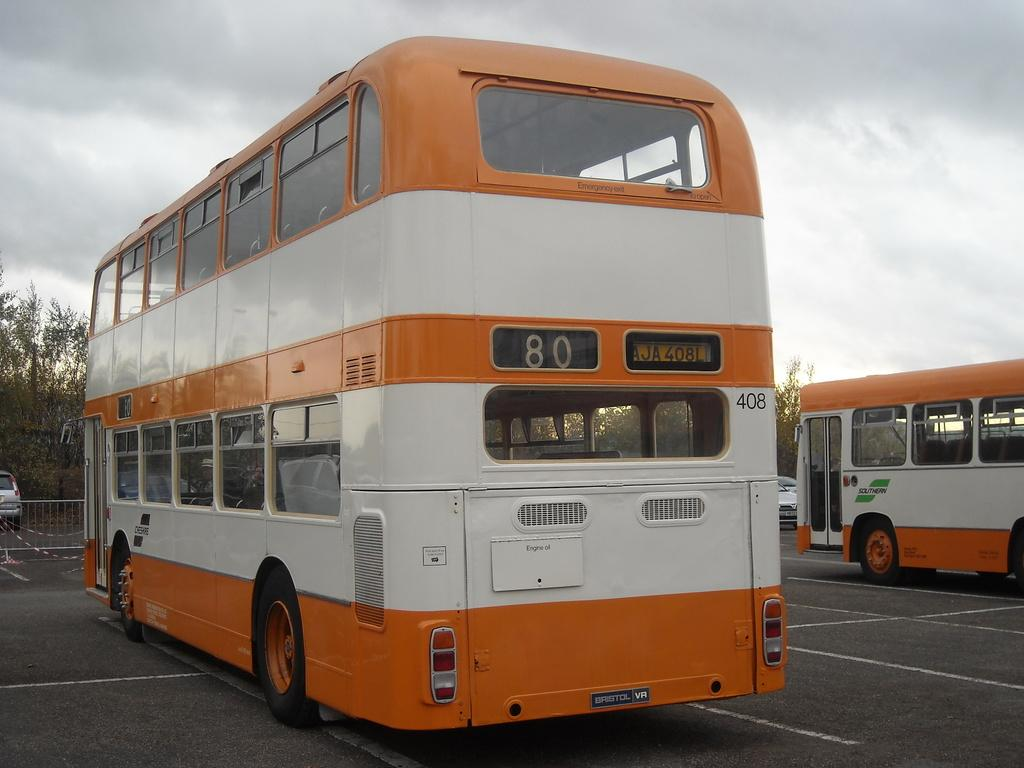What can be seen on the road in the image? There are vehicles on the road in the image. What is located near the road in the image? There is a fence in the image. What type of natural scenery is visible in the background of the image? There are trees in the background of the image. What is visible above the scene in the image? The sky is visible in the image. What can be observed in the sky in the image? Clouds are present in the sky. Is there any milk being poured in the image? There is no milk present in the image. Can you see anyone reading a book in the image? There is no one reading a book in the image. 